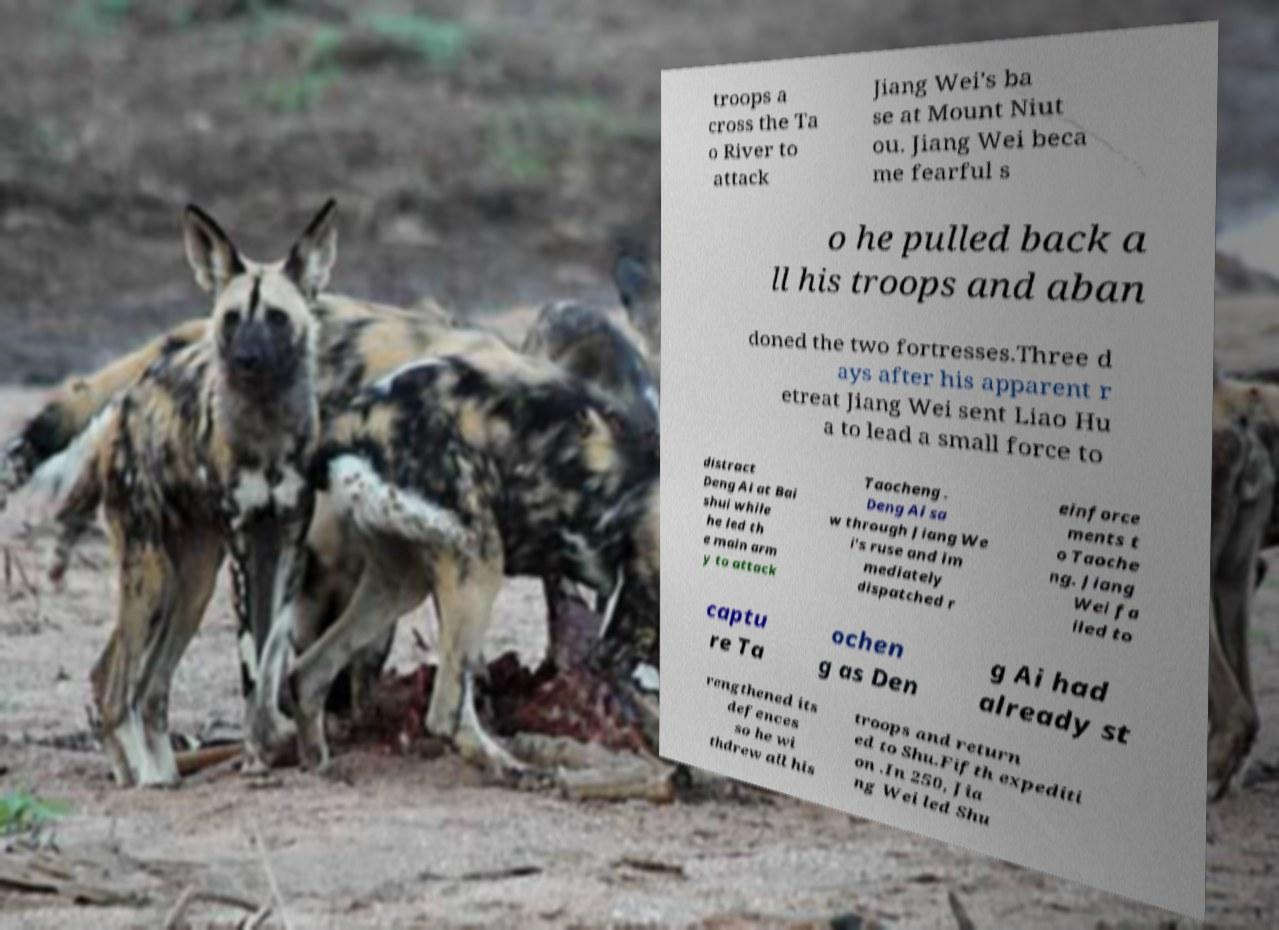There's text embedded in this image that I need extracted. Can you transcribe it verbatim? troops a cross the Ta o River to attack Jiang Wei's ba se at Mount Niut ou. Jiang Wei beca me fearful s o he pulled back a ll his troops and aban doned the two fortresses.Three d ays after his apparent r etreat Jiang Wei sent Liao Hu a to lead a small force to distract Deng Ai at Bai shui while he led th e main arm y to attack Taocheng . Deng Ai sa w through Jiang We i's ruse and im mediately dispatched r einforce ments t o Taoche ng. Jiang Wei fa iled to captu re Ta ochen g as Den g Ai had already st rengthened its defences so he wi thdrew all his troops and return ed to Shu.Fifth expediti on .In 250, Jia ng Wei led Shu 